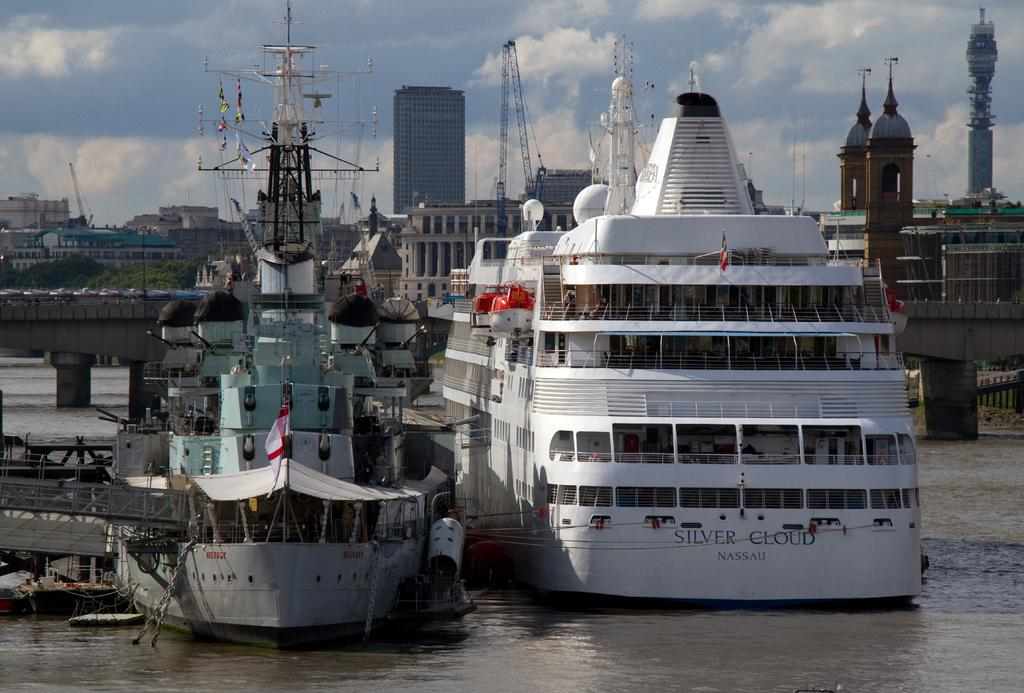Provide a one-sentence caption for the provided image. the ship silver cloud anchored next to a ship flying the English flag. 